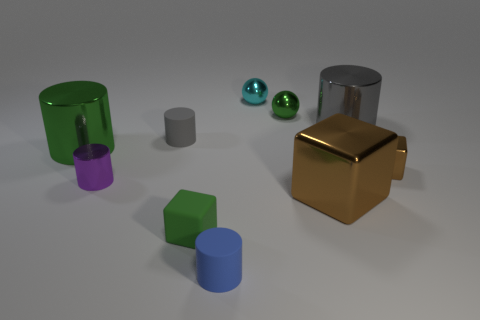There is a sphere that is the same color as the matte cube; what is its material?
Provide a succinct answer. Metal. How many small rubber things are to the left of the brown shiny cube on the right side of the large gray metallic cylinder?
Make the answer very short. 3. There is a small block that is made of the same material as the small cyan ball; what is its color?
Ensure brevity in your answer.  Brown. Is there a matte cube that has the same size as the purple cylinder?
Keep it short and to the point. Yes. What is the shape of the purple metallic thing that is the same size as the blue object?
Make the answer very short. Cylinder. Are there any big green shiny objects of the same shape as the small blue rubber object?
Your answer should be compact. Yes. Is the green cylinder made of the same material as the brown object that is behind the big brown block?
Your response must be concise. Yes. Is there a small ball of the same color as the large block?
Provide a short and direct response. No. What number of other objects are there of the same material as the green sphere?
Make the answer very short. 6. Does the small metallic cube have the same color as the tiny matte thing in front of the tiny matte block?
Offer a very short reply. No. 